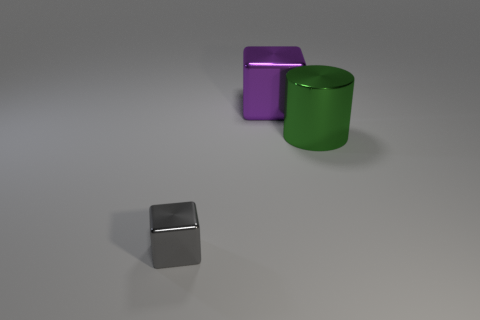What is the size of the other object that is the same shape as the gray metallic object?
Provide a short and direct response. Large. Do the cylinder and the large metallic cube have the same color?
Ensure brevity in your answer.  No. There is a thing that is to the left of the large object on the left side of the green metallic thing; what number of small gray metallic blocks are in front of it?
Your answer should be very brief. 0. Is the number of gray metal things greater than the number of tiny green shiny cubes?
Ensure brevity in your answer.  Yes. What number of big gray matte objects are there?
Provide a short and direct response. 0. What is the shape of the thing behind the thing that is on the right side of the block that is to the right of the tiny thing?
Ensure brevity in your answer.  Cube. Are there fewer tiny blocks left of the gray metallic thing than big green cylinders that are left of the large shiny block?
Keep it short and to the point. No. Is the shape of the shiny thing behind the large green shiny object the same as the big shiny object on the right side of the purple thing?
Offer a very short reply. No. There is a big shiny thing that is in front of the cube on the right side of the gray metal block; what is its shape?
Offer a very short reply. Cylinder. Are there any gray cubes made of the same material as the purple block?
Offer a terse response. Yes. 